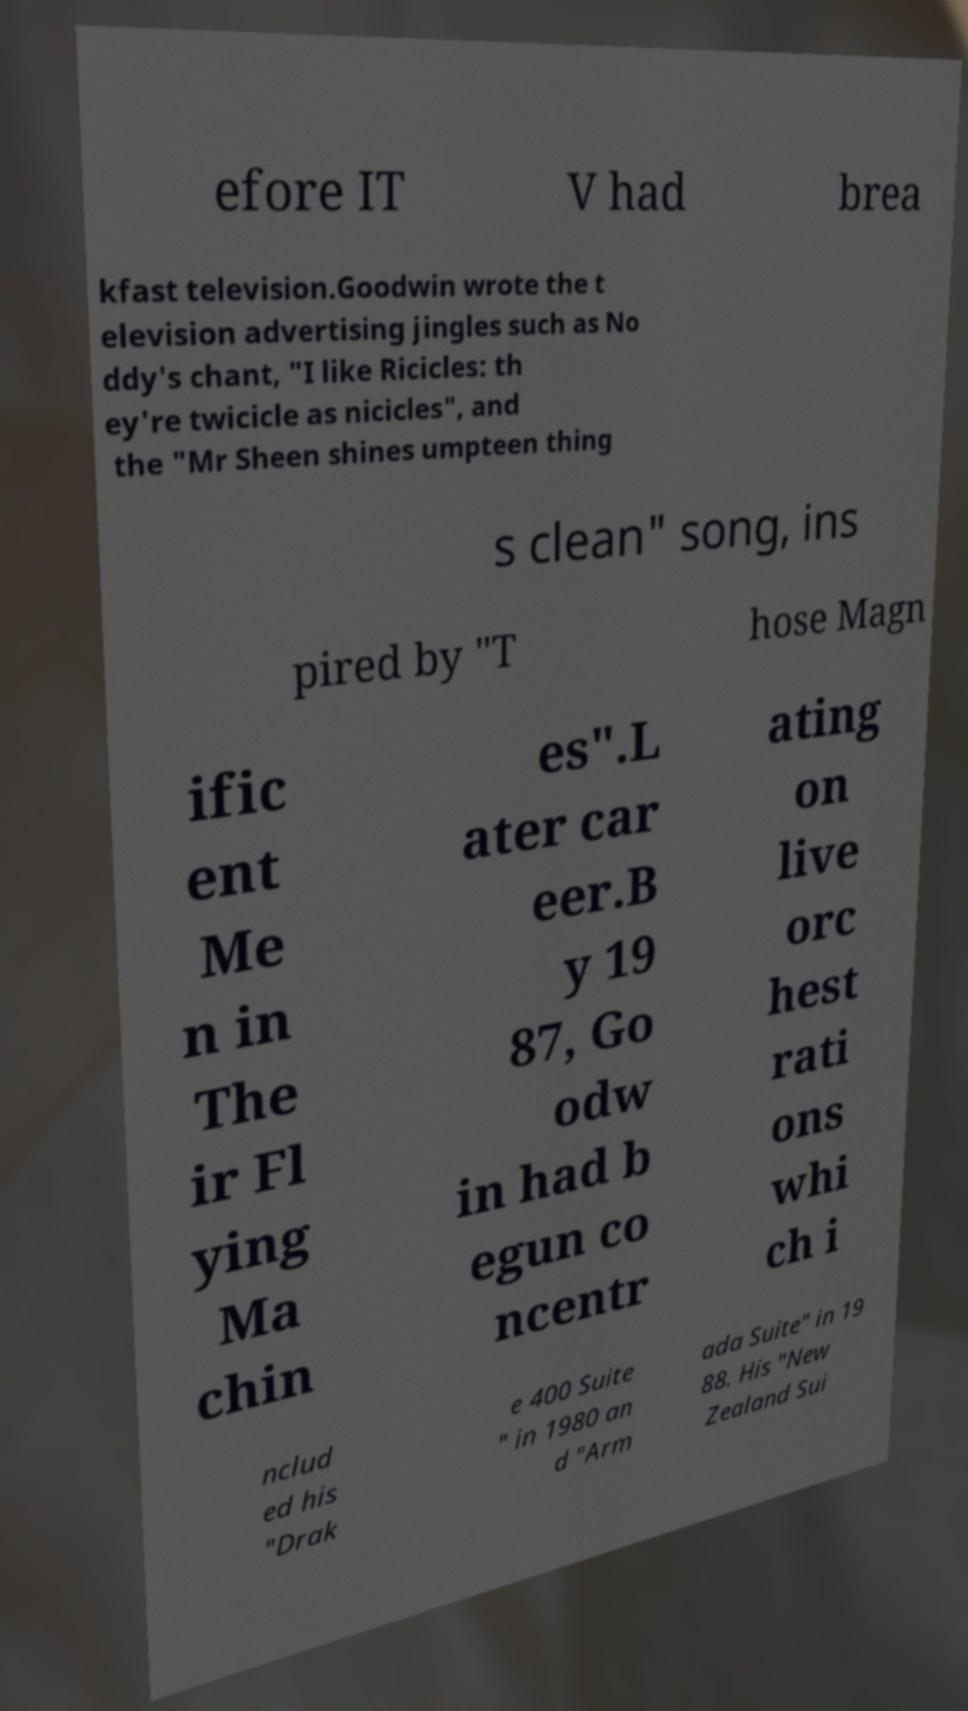I need the written content from this picture converted into text. Can you do that? efore IT V had brea kfast television.Goodwin wrote the t elevision advertising jingles such as No ddy's chant, "I like Ricicles: th ey're twicicle as nicicles", and the "Mr Sheen shines umpteen thing s clean" song, ins pired by "T hose Magn ific ent Me n in The ir Fl ying Ma chin es".L ater car eer.B y 19 87, Go odw in had b egun co ncentr ating on live orc hest rati ons whi ch i nclud ed his "Drak e 400 Suite " in 1980 an d "Arm ada Suite" in 19 88. His "New Zealand Sui 